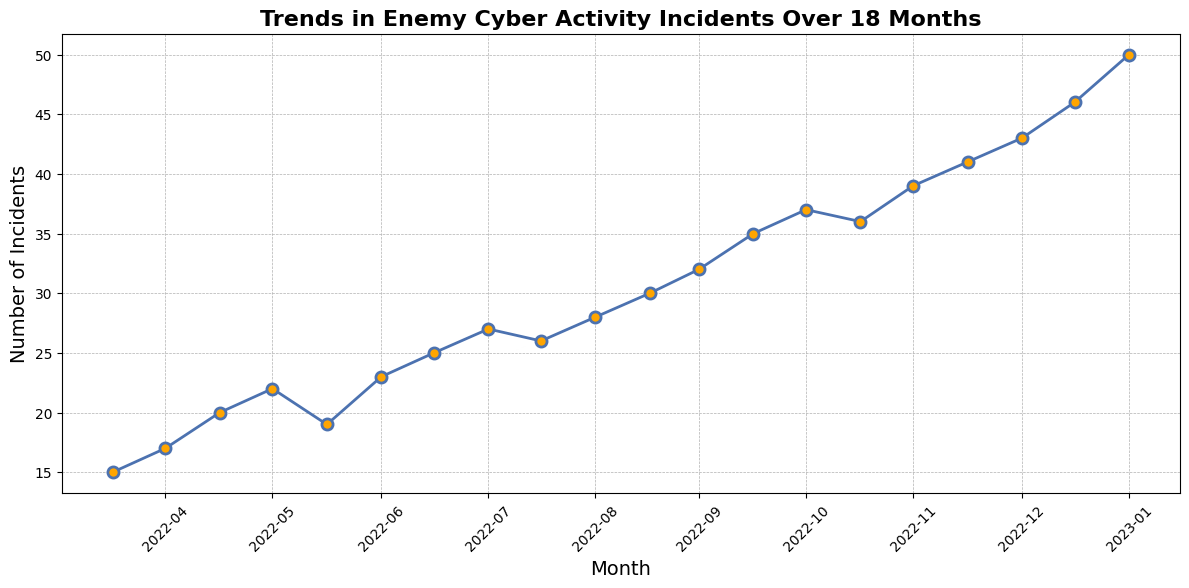What trend can be observed in enemy cyber activity incidents from April 2022 to November 2023? The plotted line shows an increasing trend in the number of incidents over time, with the number increasing from 15 incidents in April 2022 to 50 incidents in November 2023.
Answer: Increasing trend Which month had the highest number of enemy cyber activity incidents? By examining the plot, the highest point on the line occurs in November 2023, indicating that this month had the highest number of incidents.
Answer: November 2023 Between which two consecutive months did the largest increase in incidents occur? To find the largest increase, we compare the differences month-by-month. The largest increase is between October 2023 (46 incidents) and November 2023 (50 incidents), which is an increase of 4 incidents.
Answer: October 2023 to November 2023 What is the average number of incidents over the 18-month period? Sum all the monthly incidents (15+17+20+22+19+23+25+27+26+28+30+32+35+37+36+39+41+43+46+50 = 581), then divide by the number of months (581/18 ≈ 32.28).
Answer: 32.28 In which months did the number of incidents decrease compared to the previous month? By checking the plot:  * August 2022 (19) compared to July 2022 (22) * December 2022 (26) compared to November 2022 (27) * June 2023 (36) compared to May 2023 (37).
Answer: August 2022, December 2022, June 2023 How many incidents occurred in the first and the last months covered in the plot, and what is their difference? The number of incidents in April 2022 is 15 and in November 2023 is 50. The difference is 50 - 15 = 35.
Answer: 35 What was the incident count in February 2023, and how does it compare to the previous month? By looking at the plot, February 2023 had 30 incidents compared to January 2023 with 28 incidents. This shows an increase of 2 incidents.
Answer: Increase by 2 Is there a period of steady increase without any decrease in the number of incidents? From the plot, from February 2023 (30 incidents) to November 2023 (50 incidents), there is a continuous rise in the number of incidents without any decrease.
Answer: February 2023 to November 2023 How did the number of incidents change from September 2022 to October 2022? By examining the plot, the number of incidents increased from 23 in September 2022 to 25 in October 2022.
Answer: Increase by 2 